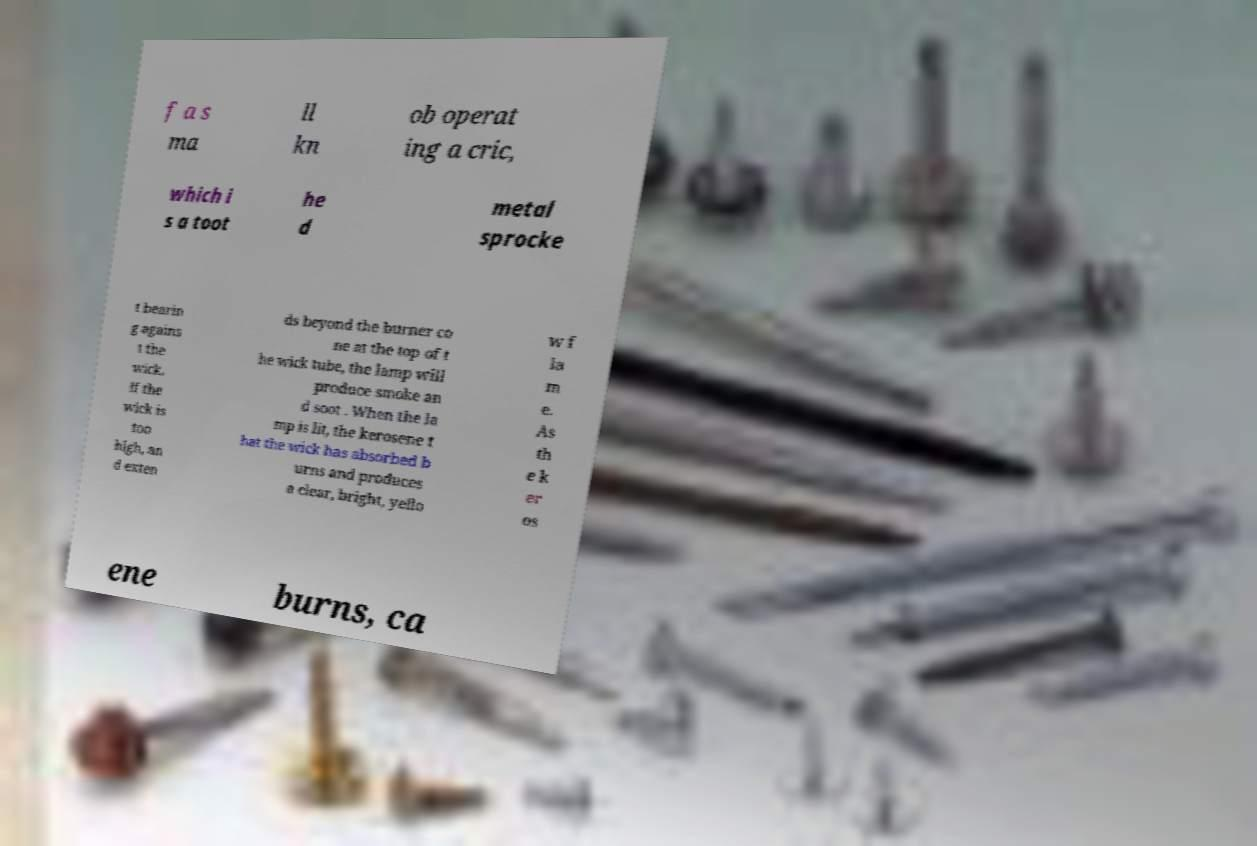Could you extract and type out the text from this image? f a s ma ll kn ob operat ing a cric, which i s a toot he d metal sprocke t bearin g agains t the wick. If the wick is too high, an d exten ds beyond the burner co ne at the top of t he wick tube, the lamp will produce smoke an d soot . When the la mp is lit, the kerosene t hat the wick has absorbed b urns and produces a clear, bright, yello w f la m e. As th e k er os ene burns, ca 